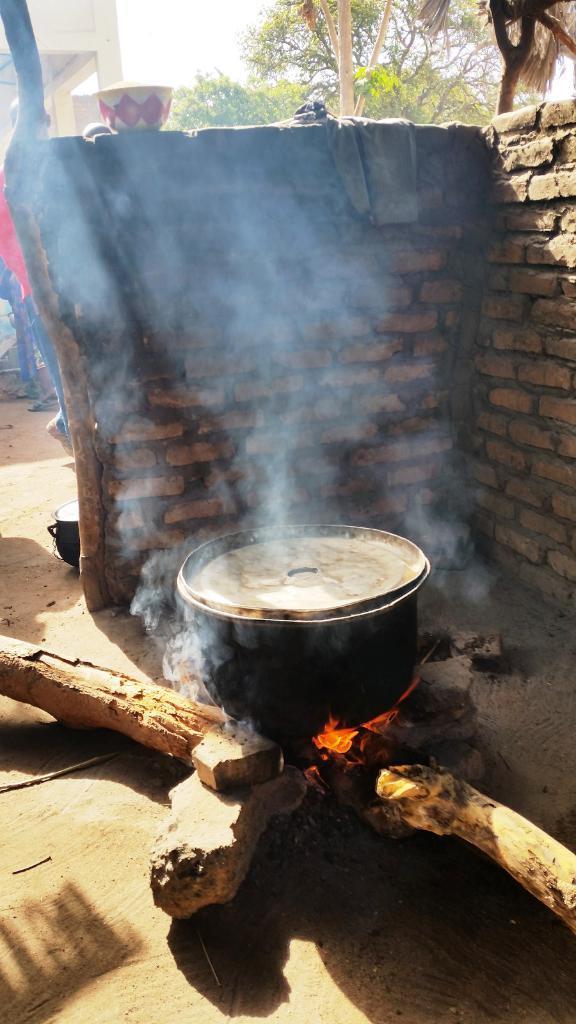How would you summarize this image in a sentence or two? In this image in the front there is a fire and on the fire there is a vessel. In the center there is a wall which is red in colour and on the wall there objects. In the background there are trees and there is a wall. 